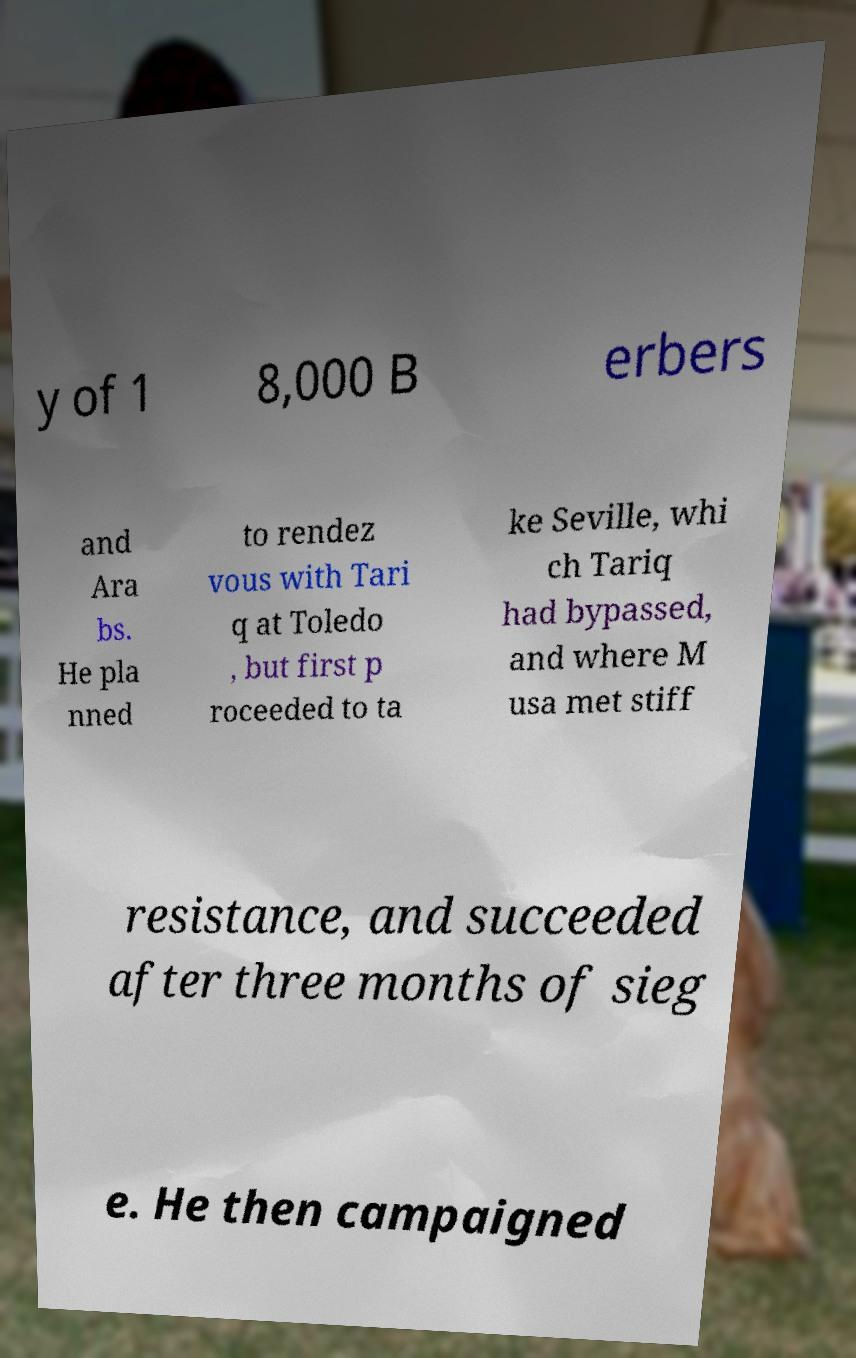Can you accurately transcribe the text from the provided image for me? y of 1 8,000 B erbers and Ara bs. He pla nned to rendez vous with Tari q at Toledo , but first p roceeded to ta ke Seville, whi ch Tariq had bypassed, and where M usa met stiff resistance, and succeeded after three months of sieg e. He then campaigned 